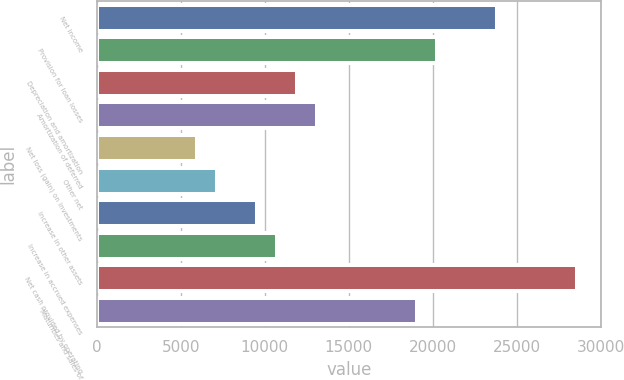<chart> <loc_0><loc_0><loc_500><loc_500><bar_chart><fcel>Net income<fcel>Provision for loan losses<fcel>Depreciation and amortization<fcel>Amortization of deferred<fcel>Net loss (gain) on investments<fcel>Other net<fcel>Increase in other assets<fcel>Increase in accrued expenses<fcel>Net cash provided by operating<fcel>Maturities and sales of<nl><fcel>23824<fcel>20251<fcel>11914<fcel>13105<fcel>5959<fcel>7150<fcel>9532<fcel>10723<fcel>28588<fcel>19060<nl></chart> 